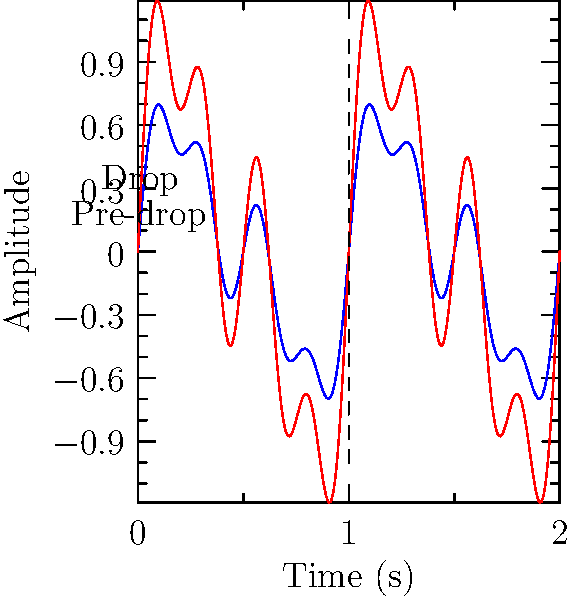In the waveform diagram above, which characteristic change most clearly indicates the occurrence of a beat drop in electronic music? To identify the beat drop in electronic music using waveform analysis, follow these steps:

1. Observe the overall amplitude: The most noticeable change during a beat drop is an increase in amplitude. In the diagram, the red waveform (after the drop) has a larger amplitude than the blue waveform (before the drop).

2. Analyze frequency content: Beat drops often introduce higher frequency components. The red waveform appears to have more rapid oscillations, suggesting increased high-frequency content.

3. Examine waveform density: The red waveform is more dense and complex, indicating more layered sounds and instruments typical of a drop.

4. Look for sudden changes: The vertical dashed line marks a clear transition point where the waveform characteristics change abruptly.

5. Consider energy levels: The increased amplitude and complexity of the red waveform suggest higher energy levels, which is characteristic of a beat drop.

The most prominent and easily identifiable change is the sudden increase in amplitude, which corresponds to the perceived increase in volume and intensity during a beat drop in electronic music.
Answer: Sudden increase in amplitude 